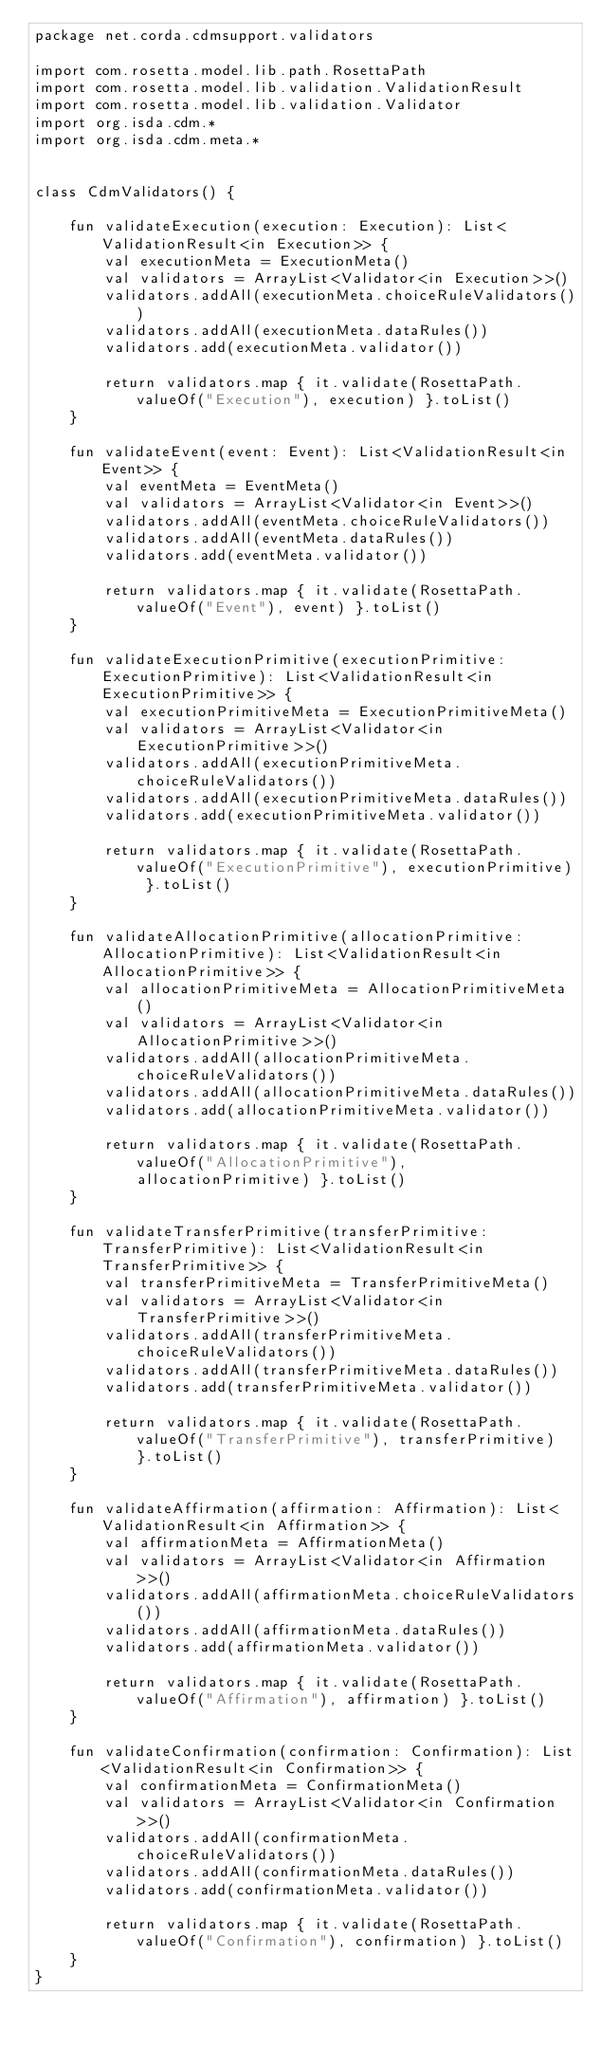Convert code to text. <code><loc_0><loc_0><loc_500><loc_500><_Kotlin_>package net.corda.cdmsupport.validators

import com.rosetta.model.lib.path.RosettaPath
import com.rosetta.model.lib.validation.ValidationResult
import com.rosetta.model.lib.validation.Validator
import org.isda.cdm.*
import org.isda.cdm.meta.*


class CdmValidators() {

    fun validateExecution(execution: Execution): List<ValidationResult<in Execution>> {
        val executionMeta = ExecutionMeta()
        val validators = ArrayList<Validator<in Execution>>()
        validators.addAll(executionMeta.choiceRuleValidators())
        validators.addAll(executionMeta.dataRules())
        validators.add(executionMeta.validator())

        return validators.map { it.validate(RosettaPath.valueOf("Execution"), execution) }.toList()
    }

    fun validateEvent(event: Event): List<ValidationResult<in Event>> {
        val eventMeta = EventMeta()
        val validators = ArrayList<Validator<in Event>>()
        validators.addAll(eventMeta.choiceRuleValidators())
        validators.addAll(eventMeta.dataRules())
        validators.add(eventMeta.validator())

        return validators.map { it.validate(RosettaPath.valueOf("Event"), event) }.toList()
    }

    fun validateExecutionPrimitive(executionPrimitive: ExecutionPrimitive): List<ValidationResult<in ExecutionPrimitive>> {
        val executionPrimitiveMeta = ExecutionPrimitiveMeta()
        val validators = ArrayList<Validator<in ExecutionPrimitive>>()
        validators.addAll(executionPrimitiveMeta.choiceRuleValidators())
        validators.addAll(executionPrimitiveMeta.dataRules())
        validators.add(executionPrimitiveMeta.validator())

        return validators.map { it.validate(RosettaPath.valueOf("ExecutionPrimitive"), executionPrimitive) }.toList()
    }

    fun validateAllocationPrimitive(allocationPrimitive: AllocationPrimitive): List<ValidationResult<in AllocationPrimitive>> {
        val allocationPrimitiveMeta = AllocationPrimitiveMeta()
        val validators = ArrayList<Validator<in AllocationPrimitive>>()
        validators.addAll(allocationPrimitiveMeta.choiceRuleValidators())
        validators.addAll(allocationPrimitiveMeta.dataRules())
        validators.add(allocationPrimitiveMeta.validator())

        return validators.map { it.validate(RosettaPath.valueOf("AllocationPrimitive"), allocationPrimitive) }.toList()
    }

    fun validateTransferPrimitive(transferPrimitive: TransferPrimitive): List<ValidationResult<in TransferPrimitive>> {
        val transferPrimitiveMeta = TransferPrimitiveMeta()
        val validators = ArrayList<Validator<in TransferPrimitive>>()
        validators.addAll(transferPrimitiveMeta.choiceRuleValidators())
        validators.addAll(transferPrimitiveMeta.dataRules())
        validators.add(transferPrimitiveMeta.validator())

        return validators.map { it.validate(RosettaPath.valueOf("TransferPrimitive"), transferPrimitive) }.toList()
    }

    fun validateAffirmation(affirmation: Affirmation): List<ValidationResult<in Affirmation>> {
        val affirmationMeta = AffirmationMeta()
        val validators = ArrayList<Validator<in Affirmation>>()
        validators.addAll(affirmationMeta.choiceRuleValidators())
        validators.addAll(affirmationMeta.dataRules())
        validators.add(affirmationMeta.validator())

        return validators.map { it.validate(RosettaPath.valueOf("Affirmation"), affirmation) }.toList()
    }

    fun validateConfirmation(confirmation: Confirmation): List<ValidationResult<in Confirmation>> {
        val confirmationMeta = ConfirmationMeta()
        val validators = ArrayList<Validator<in Confirmation>>()
        validators.addAll(confirmationMeta.choiceRuleValidators())
        validators.addAll(confirmationMeta.dataRules())
        validators.add(confirmationMeta.validator())

        return validators.map { it.validate(RosettaPath.valueOf("Confirmation"), confirmation) }.toList()
    }
}
</code> 